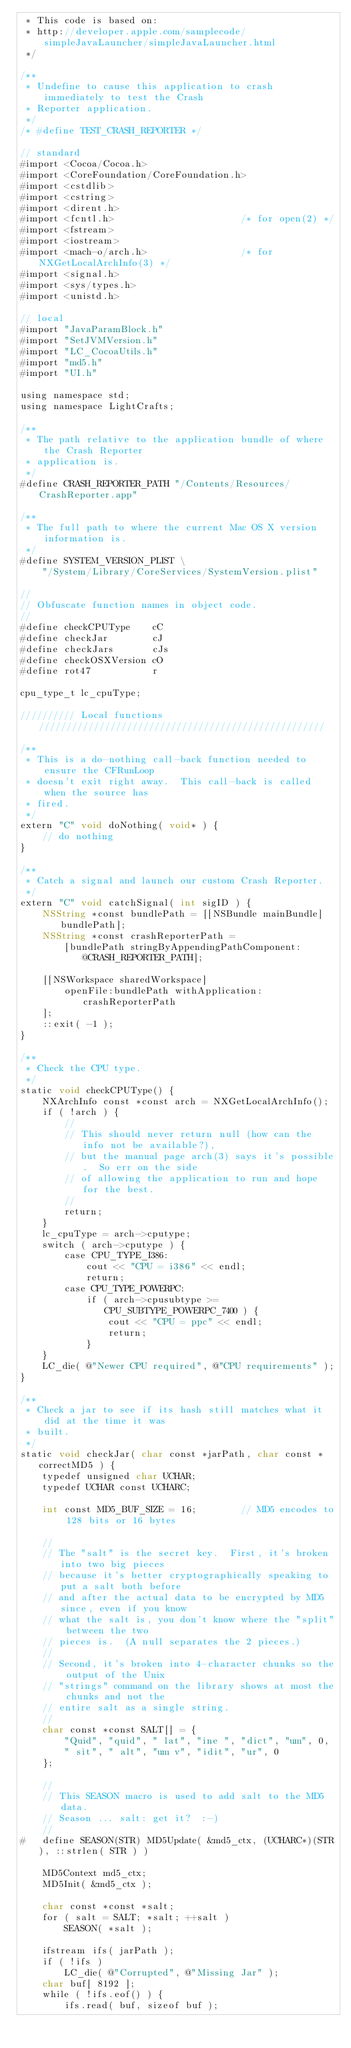Convert code to text. <code><loc_0><loc_0><loc_500><loc_500><_ObjectiveC_> * This code is based on:
 * http://developer.apple.com/samplecode/simpleJavaLauncher/simpleJavaLauncher.html
 */

/**
 * Undefine to cause this application to crash immediately to test the Crash
 * Reporter application.
 */
/* #define TEST_CRASH_REPORTER */

// standard
#import <Cocoa/Cocoa.h>
#import <CoreFoundation/CoreFoundation.h>
#import <cstdlib>
#import <cstring>
#import <dirent.h>
#import <fcntl.h>                       /* for open(2) */
#import <fstream>
#import <iostream>
#import <mach-o/arch.h>                 /* for NXGetLocalArchInfo(3) */
#import <signal.h>
#import <sys/types.h>
#import <unistd.h>

// local
#import "JavaParamBlock.h"
#import "SetJVMVersion.h"
#import "LC_CocoaUtils.h"
#import "md5.h"
#import "UI.h"

using namespace std;
using namespace LightCrafts;

/**
 * The path relative to the application bundle of where the Crash Reporter
 * application is.
 */
#define CRASH_REPORTER_PATH "/Contents/Resources/CrashReporter.app"

/**
 * The full path to where the current Mac OS X version information is.
 */
#define SYSTEM_VERSION_PLIST \
    "/System/Library/CoreServices/SystemVersion.plist"

//
// Obfuscate function names in object code.
//
#define checkCPUType    cC
#define checkJar        cJ
#define checkJars       cJs
#define checkOSXVersion cO
#define rot47           r

cpu_type_t lc_cpuType;

////////// Local functions ////////////////////////////////////////////////////

/**
 * This is a do-nothing call-back function needed to ensure the CFRunLoop
 * doesn't exit right away.  This call-back is called when the source has
 * fired.
 */
extern "C" void doNothing( void* ) {
    // do nothing
}

/**
 * Catch a signal and launch our custom Crash Reporter.
 */
extern "C" void catchSignal( int sigID ) {
    NSString *const bundlePath = [[NSBundle mainBundle] bundlePath];
    NSString *const crashReporterPath =
        [bundlePath stringByAppendingPathComponent:@CRASH_REPORTER_PATH];

    [[NSWorkspace sharedWorkspace]
        openFile:bundlePath withApplication:crashReporterPath
    ];
    ::exit( -1 );
}

/**
 * Check the CPU type.
 */
static void checkCPUType() {
    NXArchInfo const *const arch = NXGetLocalArchInfo();
    if ( !arch ) {
        //
        // This should never return null (how can the info not be available?),
        // but the manual page arch(3) says it's possible.  So err on the side
        // of allowing the application to run and hope for the best.
        //
        return;
    }
    lc_cpuType = arch->cputype;
    switch ( arch->cputype ) {
        case CPU_TYPE_I386:
            cout << "CPU = i386" << endl;
            return;
        case CPU_TYPE_POWERPC:
            if ( arch->cpusubtype >= CPU_SUBTYPE_POWERPC_7400 ) {
                cout << "CPU = ppc" << endl;
                return;
            }
    }
    LC_die( @"Newer CPU required", @"CPU requirements" );
}

/**
 * Check a jar to see if its hash still matches what it did at the time it was
 * built.
 */
static void checkJar( char const *jarPath, char const *correctMD5 ) {
    typedef unsigned char UCHAR;
    typedef UCHAR const UCHARC;

    int const MD5_BUF_SIZE = 16;        // MD5 encodes to 128 bits or 16 bytes

    //
    // The "salt" is the secret key.  First, it's broken into two big pieces
    // because it's better cryptographically speaking to put a salt both before
    // and after the actual data to be encrypted by MD5 since, even if you know
    // what the salt is, you don't know where the "split" between the two
    // pieces is.  (A null separates the 2 pieces.)
    //
    // Second, it's broken into 4-character chunks so the output of the Unix
    // "strings" command on the library shows at most the chunks and not the
    // entire salt as a single string.
    //
    char const *const SALT[] = {
        "Quid", "quid", " lat", "ine ", "dict", "um", 0,
        " sit", " alt", "um v", "idit", "ur", 0 
    };  

    //
    // This SEASON macro is used to add salt to the MD5 data.
    // Season ... salt: get it?  :-)
    //
#   define SEASON(STR) MD5Update( &md5_ctx, (UCHARC*)(STR), ::strlen( STR ) )

    MD5Context md5_ctx;
    MD5Init( &md5_ctx );

    char const *const *salt;
    for ( salt = SALT; *salt; ++salt )
        SEASON( *salt );

    ifstream ifs( jarPath );
    if ( !ifs )
        LC_die( @"Corrupted", @"Missing Jar" );
    char buf[ 8192 ];
    while ( !ifs.eof() ) {
        ifs.read( buf, sizeof buf );</code> 